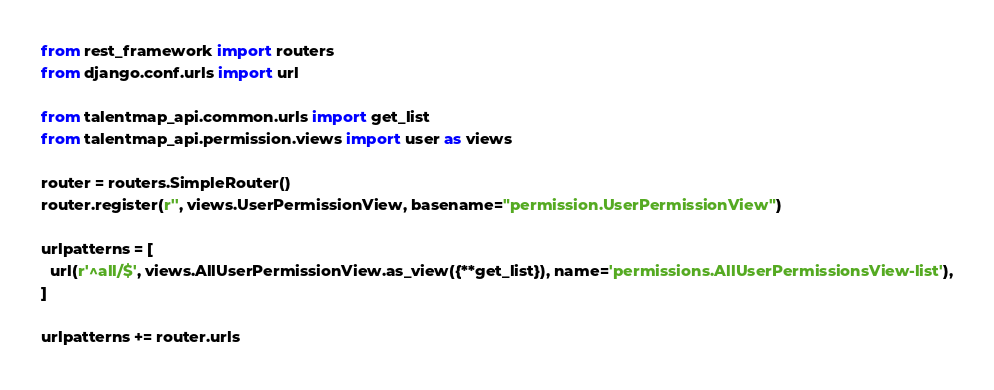<code> <loc_0><loc_0><loc_500><loc_500><_Python_>from rest_framework import routers
from django.conf.urls import url

from talentmap_api.common.urls import get_list
from talentmap_api.permission.views import user as views

router = routers.SimpleRouter()
router.register(r'', views.UserPermissionView, basename="permission.UserPermissionView")

urlpatterns = [
  url(r'^all/$', views.AllUserPermissionView.as_view({**get_list}), name='permissions.AllUserPermissionsView-list'),
]

urlpatterns += router.urls
</code> 